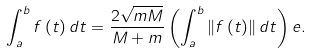<formula> <loc_0><loc_0><loc_500><loc_500>\int _ { a } ^ { b } f \left ( t \right ) d t = \frac { 2 \sqrt { m M } } { M + m } \left ( \int _ { a } ^ { b } \left \| f \left ( t \right ) \right \| d t \right ) e .</formula> 